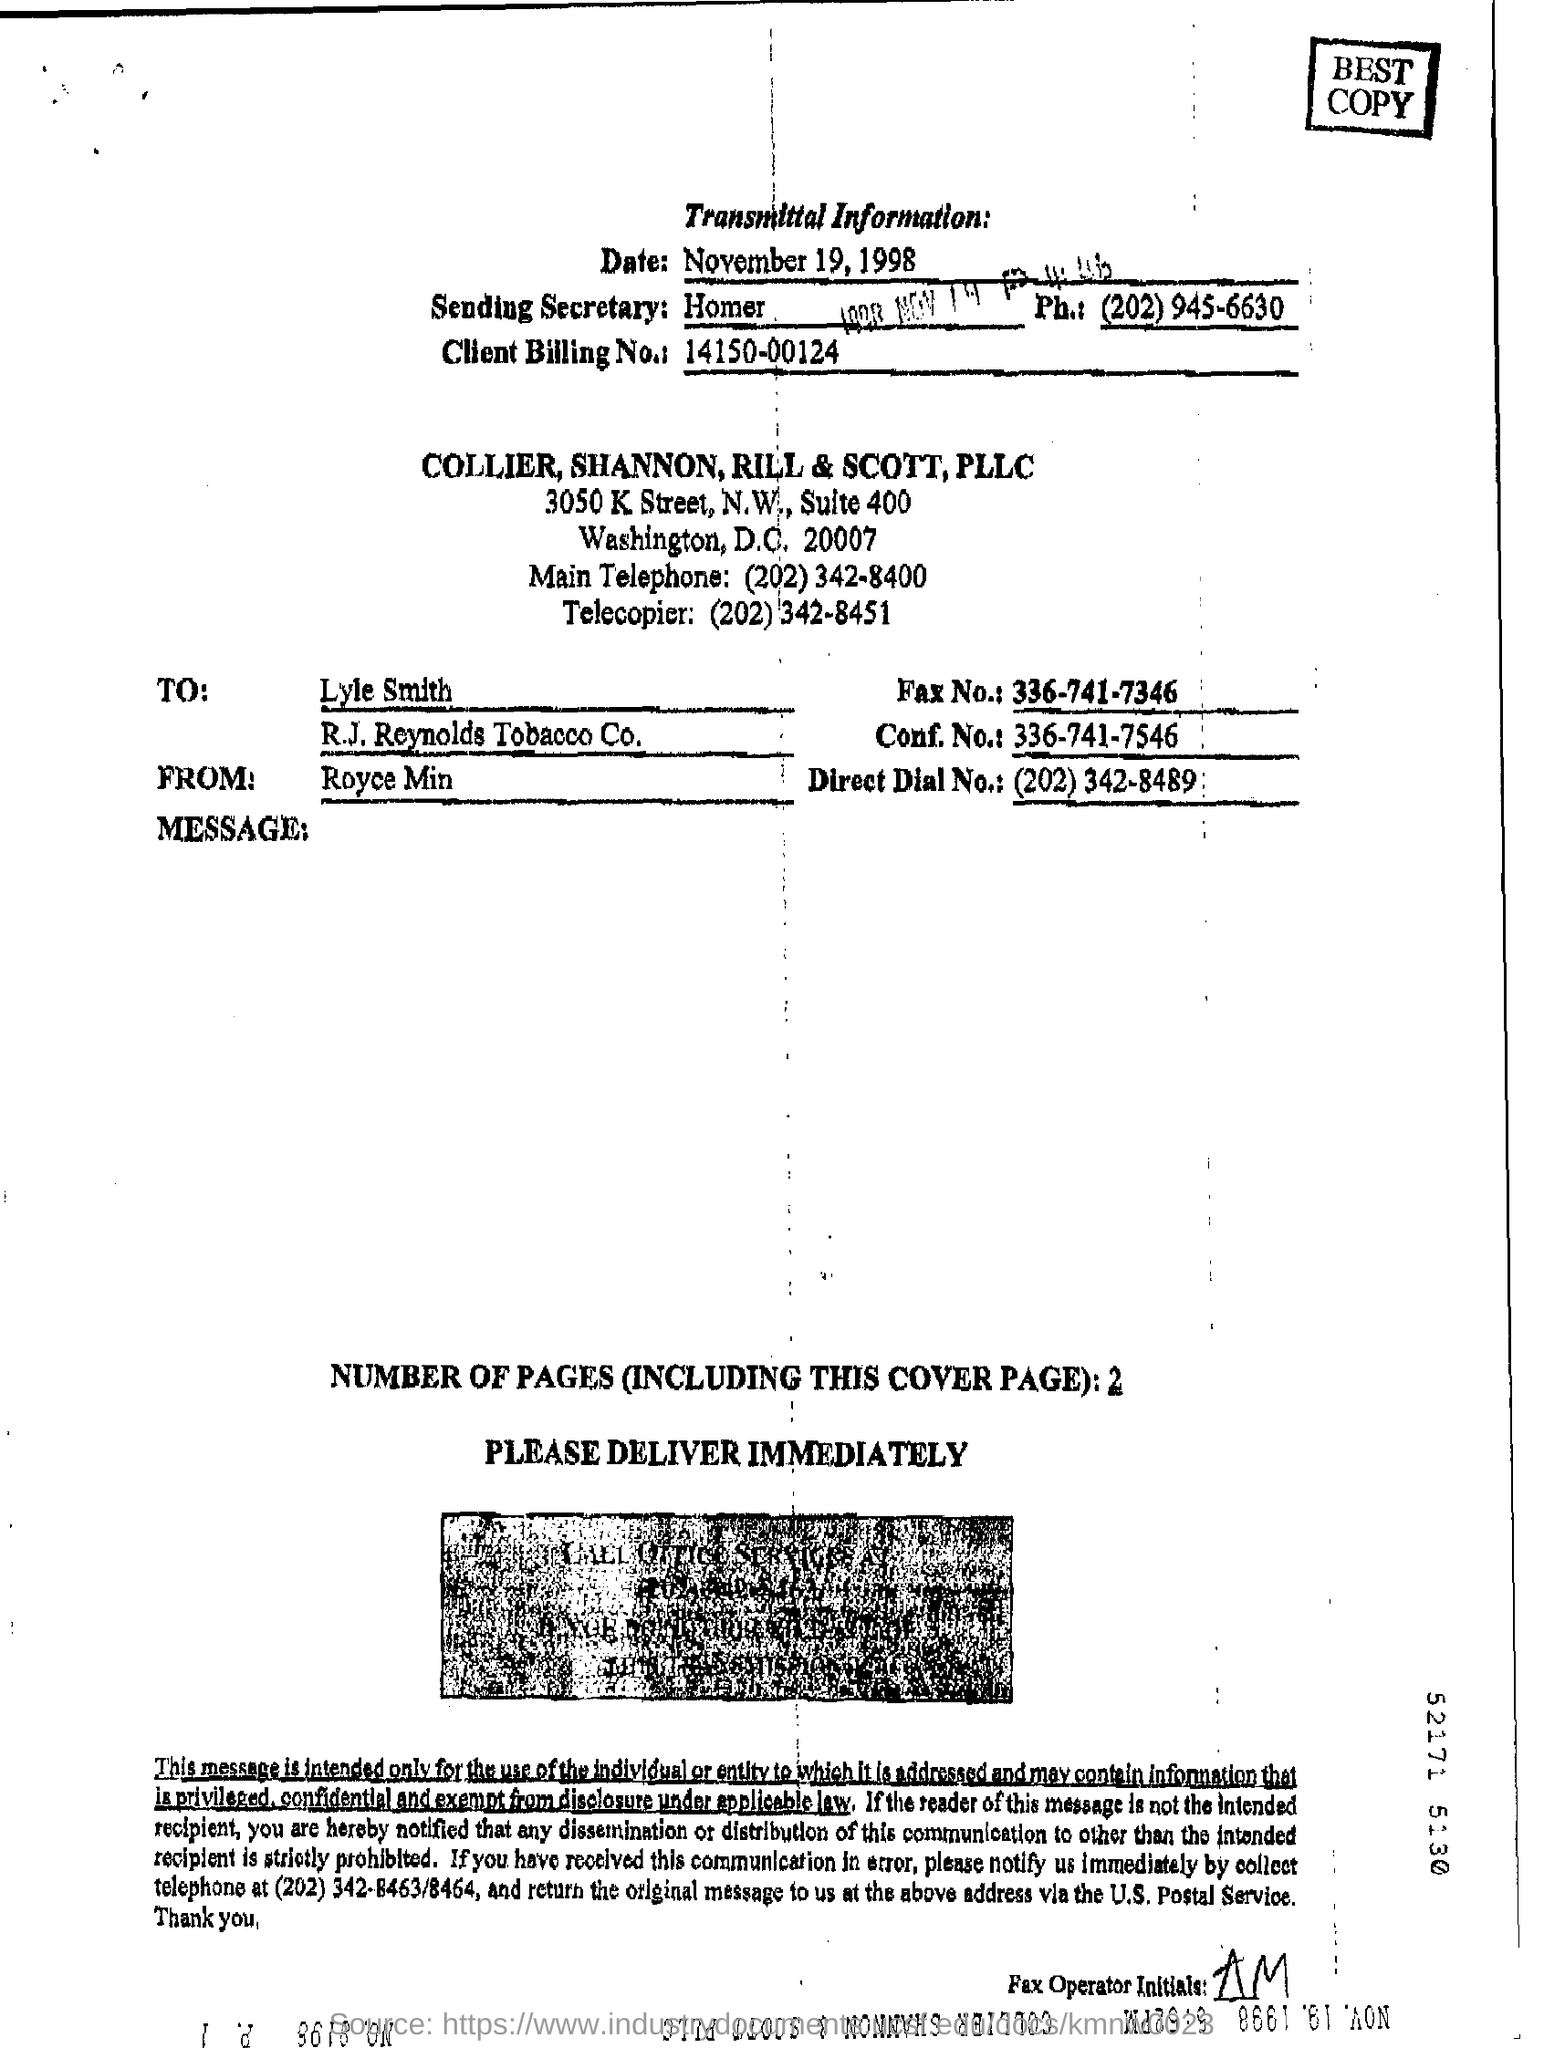Identify some key points in this picture. The client billing number is 14150-00124. The recipient of the message is Lyle Smith. 